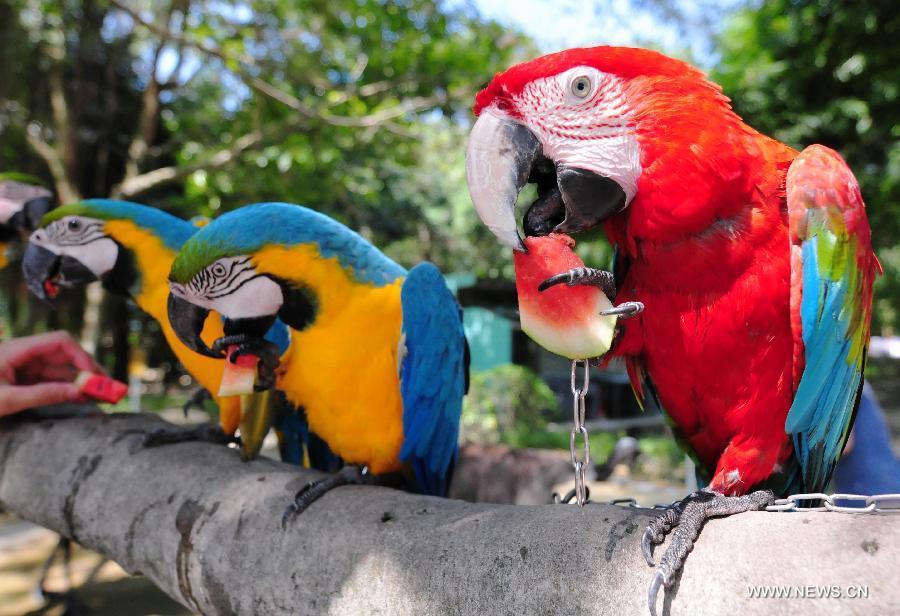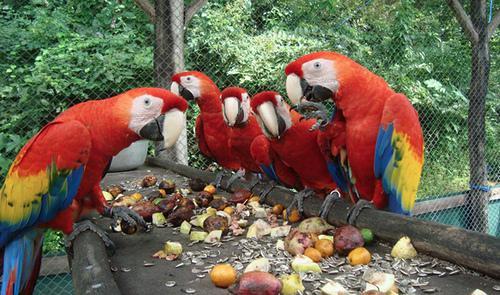The first image is the image on the left, the second image is the image on the right. Considering the images on both sides, is "The right image contains no more than one parrot." valid? Answer yes or no. No. 